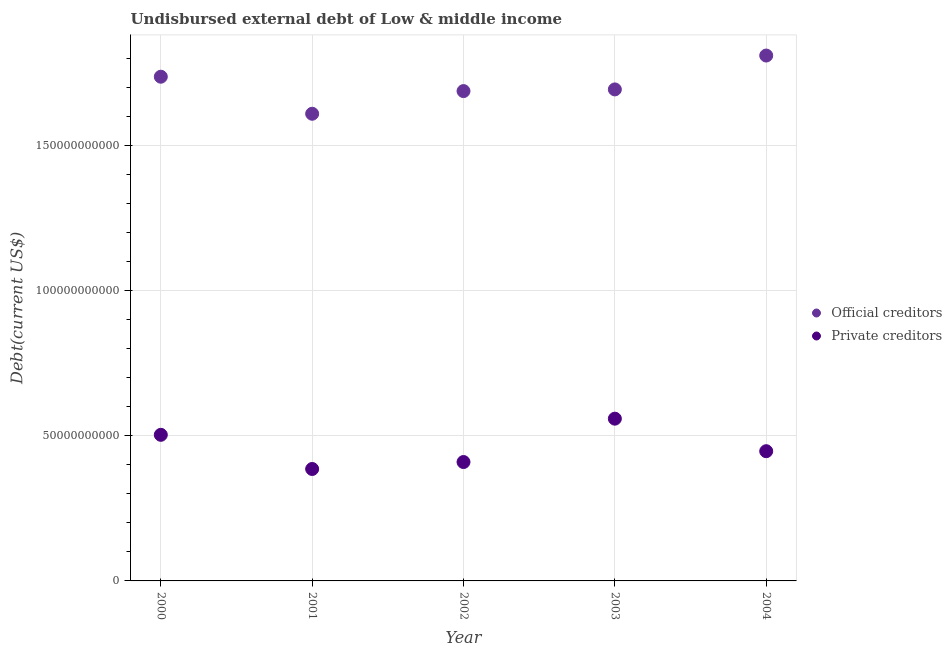How many different coloured dotlines are there?
Your answer should be very brief. 2. Is the number of dotlines equal to the number of legend labels?
Your response must be concise. Yes. What is the undisbursed external debt of private creditors in 2004?
Provide a short and direct response. 4.47e+1. Across all years, what is the maximum undisbursed external debt of official creditors?
Provide a short and direct response. 1.81e+11. Across all years, what is the minimum undisbursed external debt of official creditors?
Your answer should be compact. 1.61e+11. What is the total undisbursed external debt of private creditors in the graph?
Keep it short and to the point. 2.31e+11. What is the difference between the undisbursed external debt of official creditors in 2002 and that in 2003?
Provide a succinct answer. -5.78e+08. What is the difference between the undisbursed external debt of official creditors in 2002 and the undisbursed external debt of private creditors in 2004?
Provide a short and direct response. 1.24e+11. What is the average undisbursed external debt of private creditors per year?
Give a very brief answer. 4.61e+1. In the year 2003, what is the difference between the undisbursed external debt of official creditors and undisbursed external debt of private creditors?
Provide a succinct answer. 1.13e+11. In how many years, is the undisbursed external debt of official creditors greater than 130000000000 US$?
Make the answer very short. 5. What is the ratio of the undisbursed external debt of official creditors in 2002 to that in 2004?
Provide a succinct answer. 0.93. Is the undisbursed external debt of official creditors in 2001 less than that in 2002?
Make the answer very short. Yes. What is the difference between the highest and the second highest undisbursed external debt of official creditors?
Keep it short and to the point. 7.29e+09. What is the difference between the highest and the lowest undisbursed external debt of official creditors?
Ensure brevity in your answer.  2.01e+1. In how many years, is the undisbursed external debt of official creditors greater than the average undisbursed external debt of official creditors taken over all years?
Make the answer very short. 2. Is the undisbursed external debt of private creditors strictly greater than the undisbursed external debt of official creditors over the years?
Your response must be concise. No. How many dotlines are there?
Your answer should be very brief. 2. What is the difference between two consecutive major ticks on the Y-axis?
Give a very brief answer. 5.00e+1. Are the values on the major ticks of Y-axis written in scientific E-notation?
Ensure brevity in your answer.  No. Does the graph contain any zero values?
Offer a very short reply. No. Does the graph contain grids?
Offer a very short reply. Yes. How are the legend labels stacked?
Make the answer very short. Vertical. What is the title of the graph?
Your answer should be compact. Undisbursed external debt of Low & middle income. What is the label or title of the Y-axis?
Provide a succinct answer. Debt(current US$). What is the Debt(current US$) in Official creditors in 2000?
Provide a succinct answer. 1.74e+11. What is the Debt(current US$) in Private creditors in 2000?
Offer a very short reply. 5.03e+1. What is the Debt(current US$) of Official creditors in 2001?
Ensure brevity in your answer.  1.61e+11. What is the Debt(current US$) of Private creditors in 2001?
Offer a very short reply. 3.86e+1. What is the Debt(current US$) in Official creditors in 2002?
Provide a succinct answer. 1.69e+11. What is the Debt(current US$) in Private creditors in 2002?
Offer a terse response. 4.10e+1. What is the Debt(current US$) in Official creditors in 2003?
Your response must be concise. 1.69e+11. What is the Debt(current US$) of Private creditors in 2003?
Your answer should be very brief. 5.59e+1. What is the Debt(current US$) of Official creditors in 2004?
Provide a short and direct response. 1.81e+11. What is the Debt(current US$) of Private creditors in 2004?
Your answer should be very brief. 4.47e+1. Across all years, what is the maximum Debt(current US$) in Official creditors?
Provide a short and direct response. 1.81e+11. Across all years, what is the maximum Debt(current US$) of Private creditors?
Provide a short and direct response. 5.59e+1. Across all years, what is the minimum Debt(current US$) in Official creditors?
Offer a very short reply. 1.61e+11. Across all years, what is the minimum Debt(current US$) of Private creditors?
Provide a succinct answer. 3.86e+1. What is the total Debt(current US$) of Official creditors in the graph?
Make the answer very short. 8.54e+11. What is the total Debt(current US$) of Private creditors in the graph?
Make the answer very short. 2.31e+11. What is the difference between the Debt(current US$) in Official creditors in 2000 and that in 2001?
Your response must be concise. 1.28e+1. What is the difference between the Debt(current US$) in Private creditors in 2000 and that in 2001?
Provide a short and direct response. 1.18e+1. What is the difference between the Debt(current US$) of Official creditors in 2000 and that in 2002?
Keep it short and to the point. 4.95e+09. What is the difference between the Debt(current US$) in Private creditors in 2000 and that in 2002?
Give a very brief answer. 9.38e+09. What is the difference between the Debt(current US$) of Official creditors in 2000 and that in 2003?
Your response must be concise. 4.37e+09. What is the difference between the Debt(current US$) in Private creditors in 2000 and that in 2003?
Your answer should be very brief. -5.56e+09. What is the difference between the Debt(current US$) of Official creditors in 2000 and that in 2004?
Offer a very short reply. -7.29e+09. What is the difference between the Debt(current US$) of Private creditors in 2000 and that in 2004?
Give a very brief answer. 5.65e+09. What is the difference between the Debt(current US$) in Official creditors in 2001 and that in 2002?
Your answer should be compact. -7.81e+09. What is the difference between the Debt(current US$) in Private creditors in 2001 and that in 2002?
Ensure brevity in your answer.  -2.40e+09. What is the difference between the Debt(current US$) of Official creditors in 2001 and that in 2003?
Offer a terse response. -8.39e+09. What is the difference between the Debt(current US$) of Private creditors in 2001 and that in 2003?
Make the answer very short. -1.73e+1. What is the difference between the Debt(current US$) of Official creditors in 2001 and that in 2004?
Your response must be concise. -2.01e+1. What is the difference between the Debt(current US$) of Private creditors in 2001 and that in 2004?
Make the answer very short. -6.13e+09. What is the difference between the Debt(current US$) in Official creditors in 2002 and that in 2003?
Provide a succinct answer. -5.78e+08. What is the difference between the Debt(current US$) of Private creditors in 2002 and that in 2003?
Provide a short and direct response. -1.49e+1. What is the difference between the Debt(current US$) of Official creditors in 2002 and that in 2004?
Provide a succinct answer. -1.22e+1. What is the difference between the Debt(current US$) of Private creditors in 2002 and that in 2004?
Keep it short and to the point. -3.73e+09. What is the difference between the Debt(current US$) in Official creditors in 2003 and that in 2004?
Give a very brief answer. -1.17e+1. What is the difference between the Debt(current US$) in Private creditors in 2003 and that in 2004?
Keep it short and to the point. 1.12e+1. What is the difference between the Debt(current US$) in Official creditors in 2000 and the Debt(current US$) in Private creditors in 2001?
Give a very brief answer. 1.35e+11. What is the difference between the Debt(current US$) in Official creditors in 2000 and the Debt(current US$) in Private creditors in 2002?
Give a very brief answer. 1.33e+11. What is the difference between the Debt(current US$) in Official creditors in 2000 and the Debt(current US$) in Private creditors in 2003?
Provide a succinct answer. 1.18e+11. What is the difference between the Debt(current US$) in Official creditors in 2000 and the Debt(current US$) in Private creditors in 2004?
Your answer should be very brief. 1.29e+11. What is the difference between the Debt(current US$) in Official creditors in 2001 and the Debt(current US$) in Private creditors in 2002?
Offer a very short reply. 1.20e+11. What is the difference between the Debt(current US$) in Official creditors in 2001 and the Debt(current US$) in Private creditors in 2003?
Offer a very short reply. 1.05e+11. What is the difference between the Debt(current US$) of Official creditors in 2001 and the Debt(current US$) of Private creditors in 2004?
Offer a very short reply. 1.16e+11. What is the difference between the Debt(current US$) of Official creditors in 2002 and the Debt(current US$) of Private creditors in 2003?
Your answer should be very brief. 1.13e+11. What is the difference between the Debt(current US$) in Official creditors in 2002 and the Debt(current US$) in Private creditors in 2004?
Ensure brevity in your answer.  1.24e+11. What is the difference between the Debt(current US$) in Official creditors in 2003 and the Debt(current US$) in Private creditors in 2004?
Provide a short and direct response. 1.25e+11. What is the average Debt(current US$) in Official creditors per year?
Provide a succinct answer. 1.71e+11. What is the average Debt(current US$) in Private creditors per year?
Provide a succinct answer. 4.61e+1. In the year 2000, what is the difference between the Debt(current US$) in Official creditors and Debt(current US$) in Private creditors?
Keep it short and to the point. 1.23e+11. In the year 2001, what is the difference between the Debt(current US$) in Official creditors and Debt(current US$) in Private creditors?
Your answer should be very brief. 1.22e+11. In the year 2002, what is the difference between the Debt(current US$) in Official creditors and Debt(current US$) in Private creditors?
Your response must be concise. 1.28e+11. In the year 2003, what is the difference between the Debt(current US$) in Official creditors and Debt(current US$) in Private creditors?
Give a very brief answer. 1.13e+11. In the year 2004, what is the difference between the Debt(current US$) of Official creditors and Debt(current US$) of Private creditors?
Give a very brief answer. 1.36e+11. What is the ratio of the Debt(current US$) in Official creditors in 2000 to that in 2001?
Offer a very short reply. 1.08. What is the ratio of the Debt(current US$) in Private creditors in 2000 to that in 2001?
Provide a succinct answer. 1.31. What is the ratio of the Debt(current US$) in Official creditors in 2000 to that in 2002?
Provide a succinct answer. 1.03. What is the ratio of the Debt(current US$) of Private creditors in 2000 to that in 2002?
Give a very brief answer. 1.23. What is the ratio of the Debt(current US$) of Official creditors in 2000 to that in 2003?
Make the answer very short. 1.03. What is the ratio of the Debt(current US$) of Private creditors in 2000 to that in 2003?
Make the answer very short. 0.9. What is the ratio of the Debt(current US$) in Official creditors in 2000 to that in 2004?
Give a very brief answer. 0.96. What is the ratio of the Debt(current US$) in Private creditors in 2000 to that in 2004?
Give a very brief answer. 1.13. What is the ratio of the Debt(current US$) in Official creditors in 2001 to that in 2002?
Offer a terse response. 0.95. What is the ratio of the Debt(current US$) of Private creditors in 2001 to that in 2002?
Your response must be concise. 0.94. What is the ratio of the Debt(current US$) in Official creditors in 2001 to that in 2003?
Provide a short and direct response. 0.95. What is the ratio of the Debt(current US$) in Private creditors in 2001 to that in 2003?
Offer a very short reply. 0.69. What is the ratio of the Debt(current US$) of Official creditors in 2001 to that in 2004?
Give a very brief answer. 0.89. What is the ratio of the Debt(current US$) of Private creditors in 2001 to that in 2004?
Give a very brief answer. 0.86. What is the ratio of the Debt(current US$) of Private creditors in 2002 to that in 2003?
Your answer should be very brief. 0.73. What is the ratio of the Debt(current US$) of Official creditors in 2002 to that in 2004?
Offer a terse response. 0.93. What is the ratio of the Debt(current US$) in Private creditors in 2002 to that in 2004?
Provide a short and direct response. 0.92. What is the ratio of the Debt(current US$) in Official creditors in 2003 to that in 2004?
Ensure brevity in your answer.  0.94. What is the ratio of the Debt(current US$) of Private creditors in 2003 to that in 2004?
Your answer should be very brief. 1.25. What is the difference between the highest and the second highest Debt(current US$) in Official creditors?
Give a very brief answer. 7.29e+09. What is the difference between the highest and the second highest Debt(current US$) of Private creditors?
Your response must be concise. 5.56e+09. What is the difference between the highest and the lowest Debt(current US$) of Official creditors?
Offer a terse response. 2.01e+1. What is the difference between the highest and the lowest Debt(current US$) of Private creditors?
Give a very brief answer. 1.73e+1. 